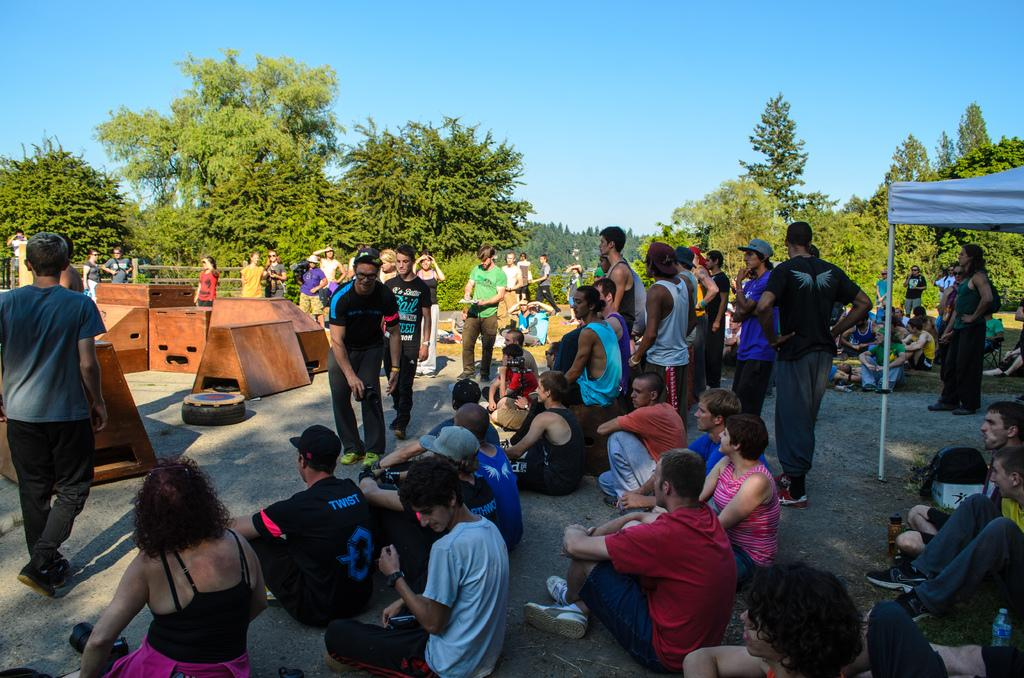Who or what can be seen in the image? There are people in the image. What type of natural elements are present in the image? There are trees in the image. What kind of objects can be seen in the image? There are wooden objects and bottles in the image. Can you describe the background of the image? There are trees in the background of the image. What is visible at the top of the image? The sky is visible at the top of the image. What type of cabbage is being used for business purposes in the image? There is no cabbage present in the image, and no business activities are depicted. 